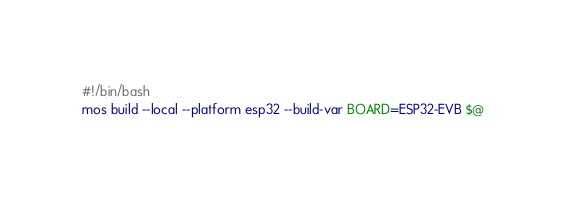<code> <loc_0><loc_0><loc_500><loc_500><_Bash_>#!/bin/bash
mos build --local --platform esp32 --build-var BOARD=ESP32-EVB $@
</code> 